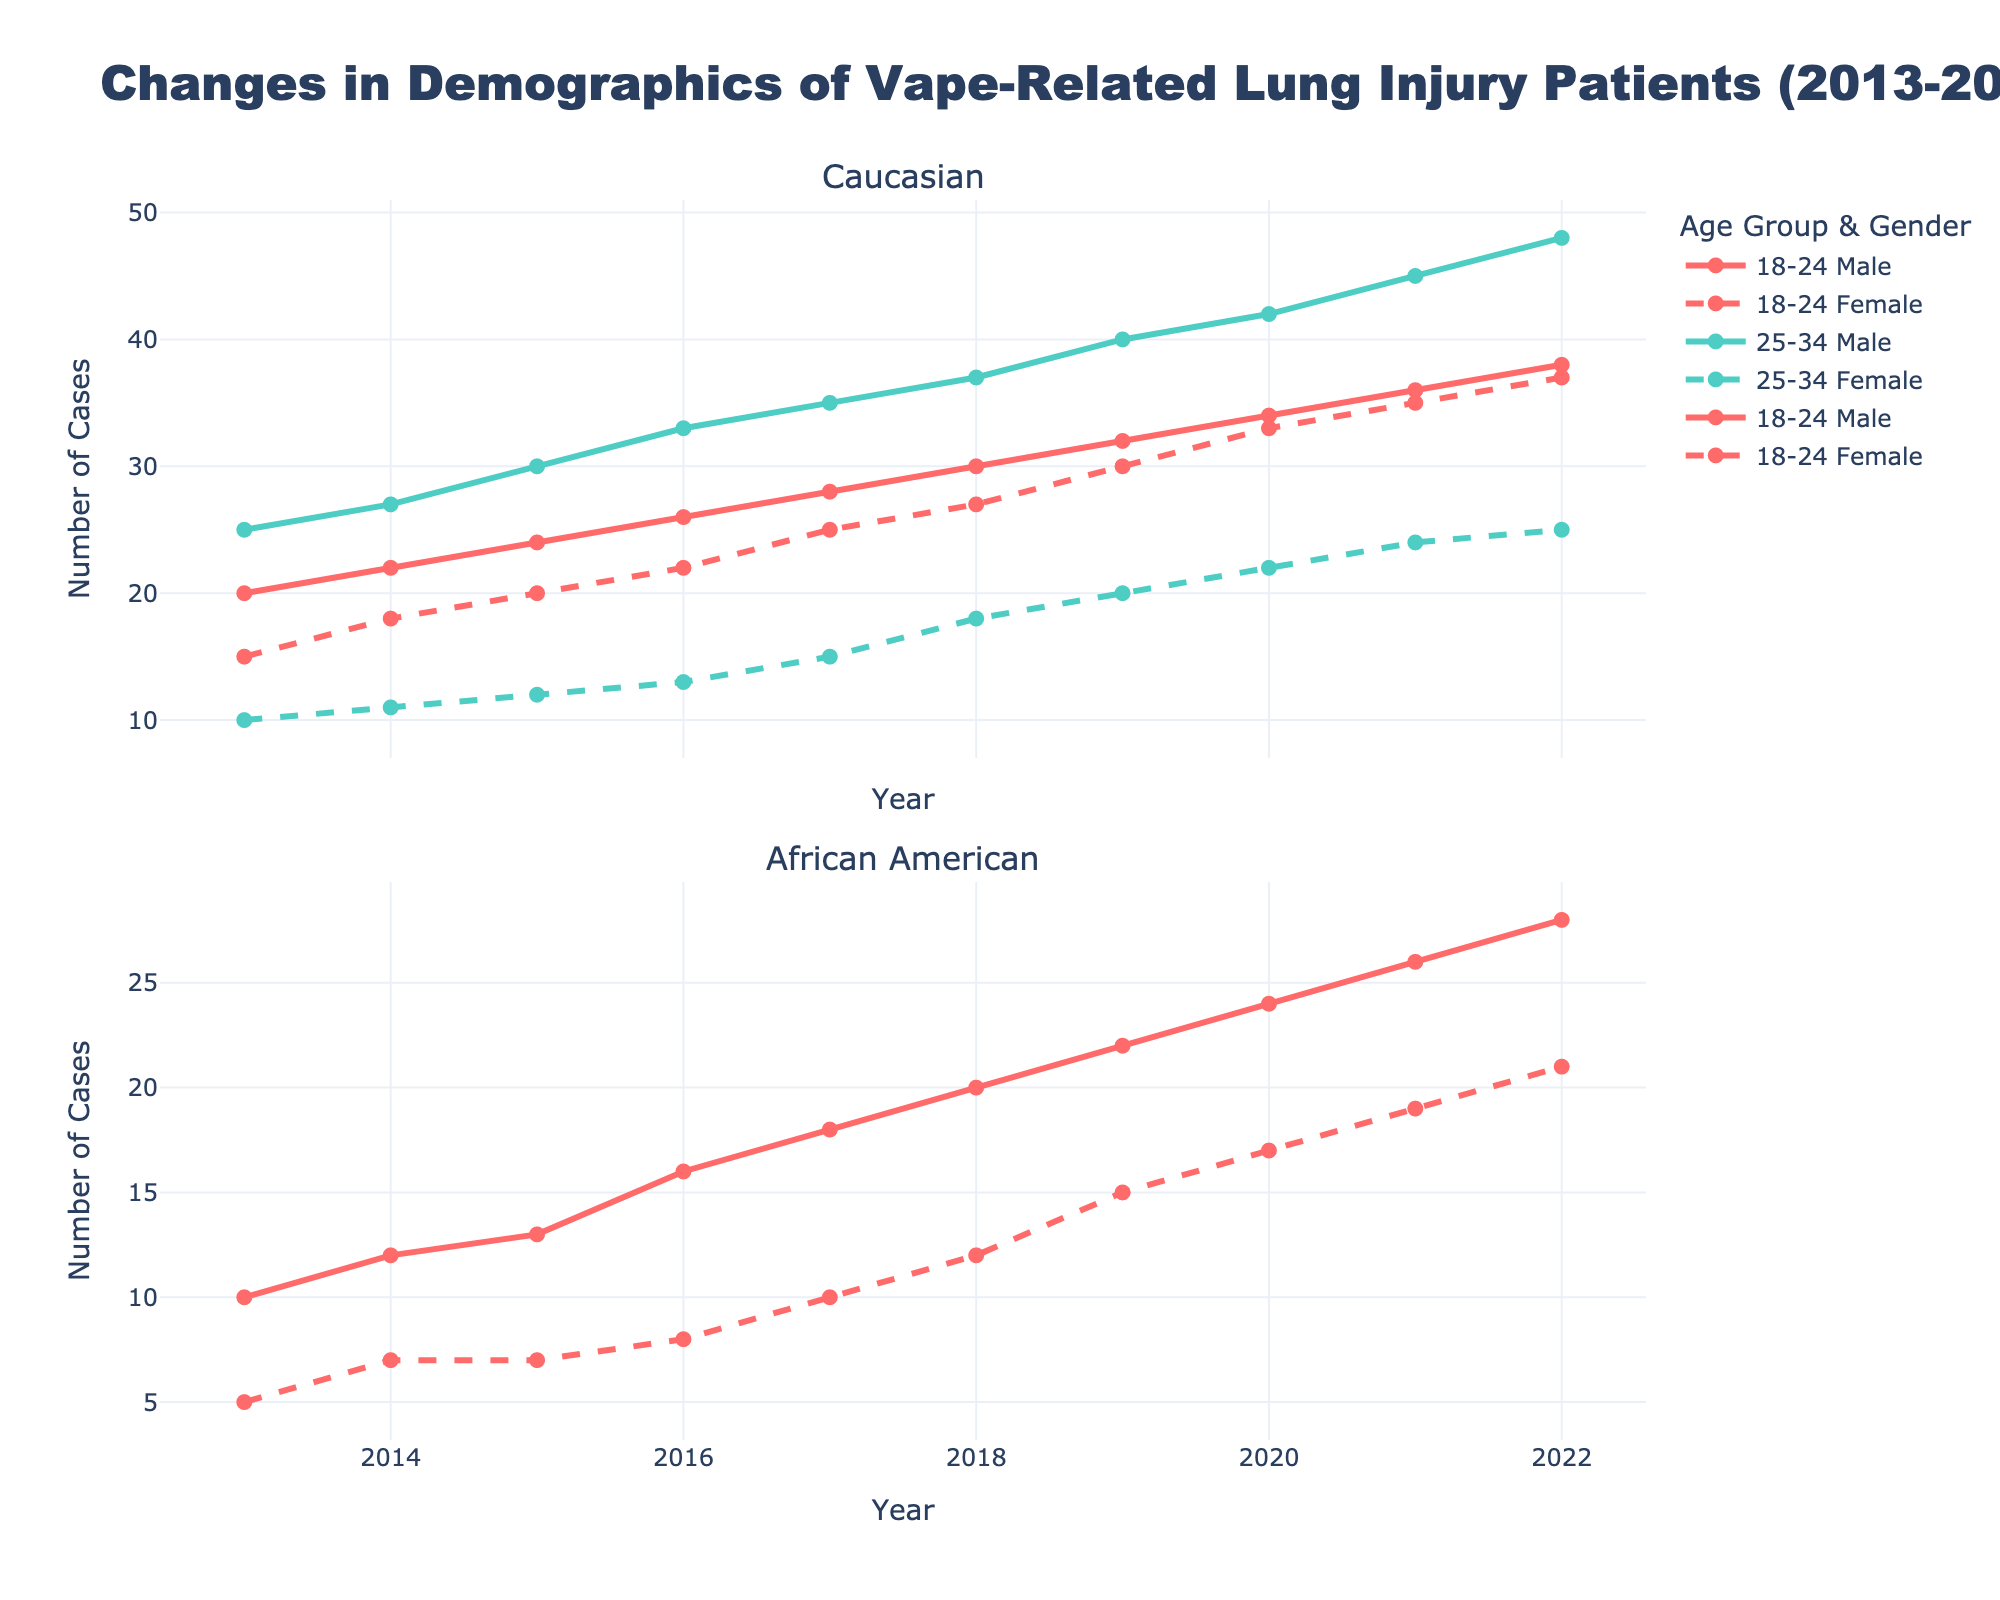What's the title of the figure? The title is usually found at the top of the figure. Here, the title is "Changes in Demographics of Vape-Related Lung Injury Patients (2013-2022)" as per the code provided.
Answer: Changes in Demographics of Vape-Related Lung Injury Patients (2013-2022) How many subplots are there, and what are their titles? The figure contains two subplots. The subplot titles are provided in the code: "Caucasian" and "African American."
Answer: Two: Caucasian and African American Which age group and gender have the most cases in 2022 among African American patients? First, look at the subplot for African American patients, then focus on the year 2022. Compare the lines based on different age groups and genders. The 18-24 age group male has the highest number at 28 cases.
Answer: 18-24 Male Which gender has seen a higher increase in cases among Caucasian patients aged 18-24 from 2013 to 2022? Examine the Caucasian subplot and focus on the 18-24 age group. Compare the changes in the number of cases for males and females from 2013 to 2022. Males increased from 20 to 38 cases, while females increased from 15 to 37 cases. Males had a higher increase (18 cases compared to 22 cases for females).
Answer: Males What's the trend of the number of cases for African American females aged 18-24 over the decade? Look at the line corresponding to African American females aged 18-24 in the African American subplot. The trend shows a gradual increase in the number of cases from 5 in 2013 to 21 in 2022. This is a clearly upward trend.
Answer: Increasing What's the difference in the number of cases for Caucasian males aged 25-34 between 2013 and 2022? Identify the data points for Caucasian males aged 25-34 in the years 2013 and 2022 in the Caucasian subplot. The number of cases in 2013 is 25 and 48 in 2022. The difference is 48 - 25 = 23 cases.
Answer: 23 cases Which age group (18-24 or 25-34) had more cases on average over the decade among Caucasian patients? Calculate the average number of cases for both age groups over the decade. Sum the cases for each year and divide by the number of years. 
For 18-24:
(20+22+24+26+28+30+32+34+36+38) / 10 = 290/10 = 29
For 25-34:
(25+27+30+33+35+37+40+42+45+48) / 10 = 362/10 = 36.2
So, the 25-34 age group has more cases on average.
Answer: 25-34 What was the number of cases for male African American patients aged 18-24 in 2018? Locate the data point for African American males aged 18-24 in 2018 from the African American subplot. The number of cases is 20.
Answer: 20 Compare the number of cases of Caucasian females aged 25-34 to Caucasian males aged 25-34 in 2021. Who had more cases? Look at the number of cases in 2021 for both Caucasian females and males aged 25-34 in the Caucasian subplot. Females had 24 cases, while males had 45 cases. Thus, males had more cases.
Answer: Males had more cases What is the slope of the number of cases for Caucasian males aged 18-24 from 2019 to 2022? To find the slope, take the difference in the number of cases between 2019 and 2022 and divide by the time difference.
Number of cases in 2019 = 32, and in 2022 = 38.
Slope = (38 - 32) / (2022 - 2019) = 6 / 3 = 2 cases per year.
Answer: 2 cases per year 